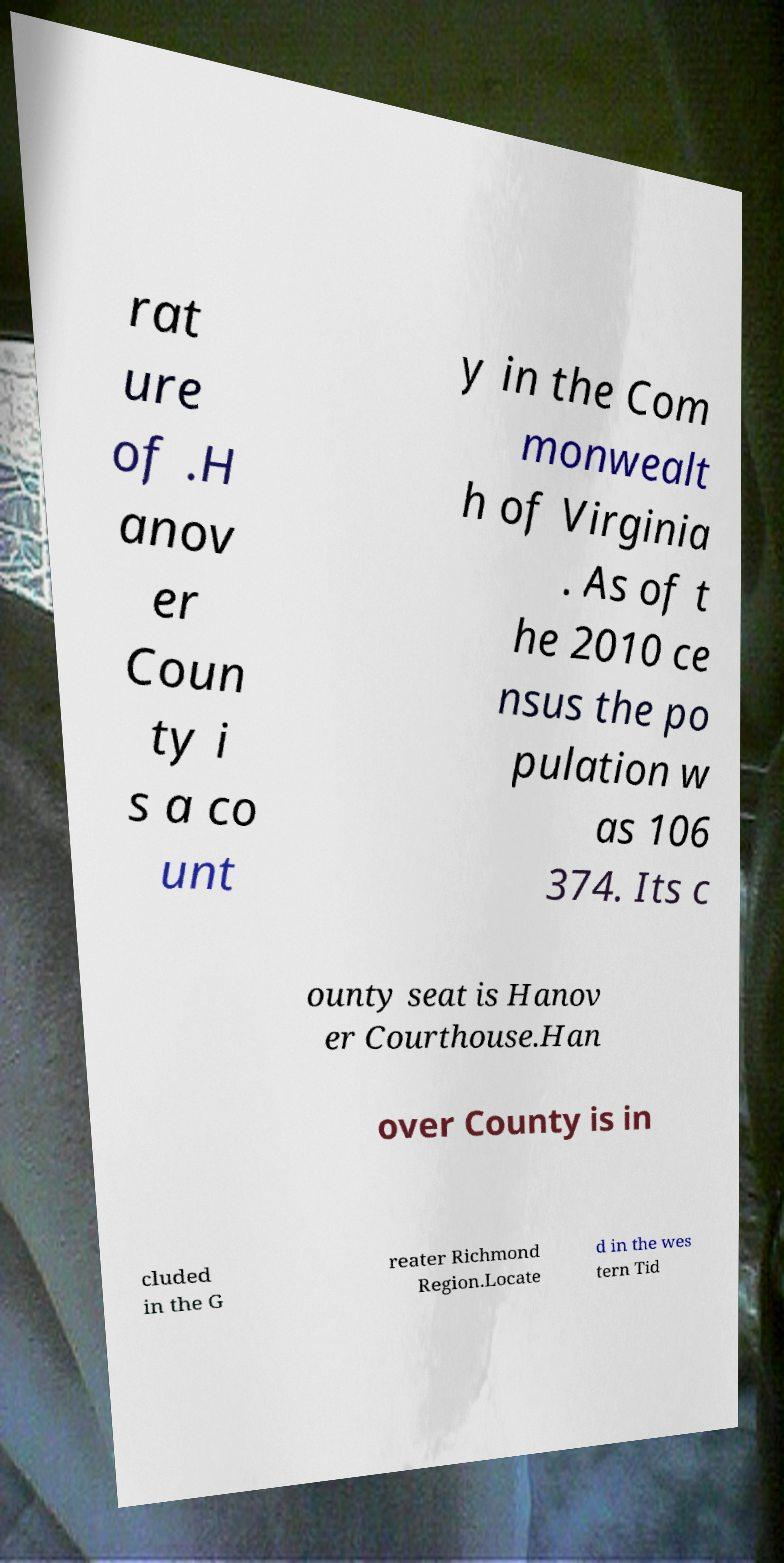I need the written content from this picture converted into text. Can you do that? rat ure of .H anov er Coun ty i s a co unt y in the Com monwealt h of Virginia . As of t he 2010 ce nsus the po pulation w as 106 374. Its c ounty seat is Hanov er Courthouse.Han over County is in cluded in the G reater Richmond Region.Locate d in the wes tern Tid 